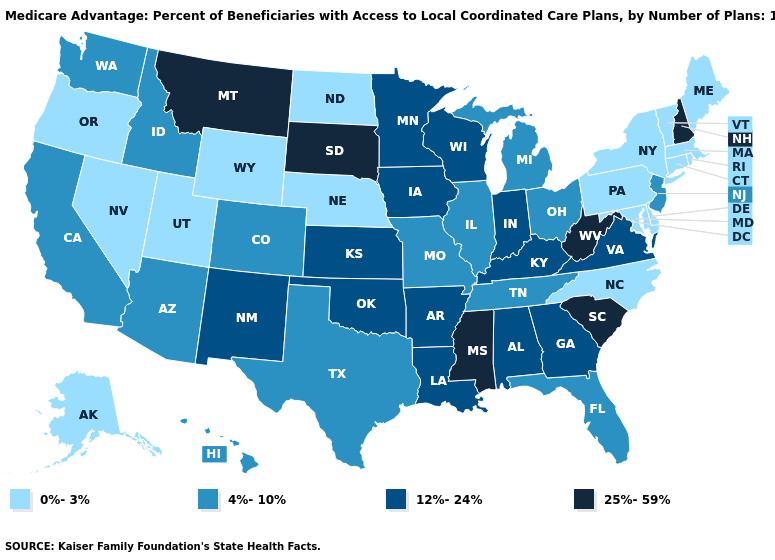Does Georgia have the highest value in the USA?
Give a very brief answer. No. Name the states that have a value in the range 0%-3%?
Write a very short answer. Alaska, Connecticut, Delaware, Massachusetts, Maryland, Maine, North Carolina, North Dakota, Nebraska, Nevada, New York, Oregon, Pennsylvania, Rhode Island, Utah, Vermont, Wyoming. What is the highest value in the USA?
Short answer required. 25%-59%. Among the states that border Maryland , which have the highest value?
Concise answer only. West Virginia. Does the first symbol in the legend represent the smallest category?
Concise answer only. Yes. Name the states that have a value in the range 4%-10%?
Answer briefly. Arizona, California, Colorado, Florida, Hawaii, Idaho, Illinois, Michigan, Missouri, New Jersey, Ohio, Tennessee, Texas, Washington. How many symbols are there in the legend?
Write a very short answer. 4. Name the states that have a value in the range 4%-10%?
Quick response, please. Arizona, California, Colorado, Florida, Hawaii, Idaho, Illinois, Michigan, Missouri, New Jersey, Ohio, Tennessee, Texas, Washington. What is the highest value in the USA?
Be succinct. 25%-59%. Name the states that have a value in the range 4%-10%?
Be succinct. Arizona, California, Colorado, Florida, Hawaii, Idaho, Illinois, Michigan, Missouri, New Jersey, Ohio, Tennessee, Texas, Washington. Name the states that have a value in the range 12%-24%?
Concise answer only. Alabama, Arkansas, Georgia, Iowa, Indiana, Kansas, Kentucky, Louisiana, Minnesota, New Mexico, Oklahoma, Virginia, Wisconsin. What is the value of Florida?
Concise answer only. 4%-10%. Among the states that border Nebraska , which have the lowest value?
Short answer required. Wyoming. What is the lowest value in states that border Mississippi?
Write a very short answer. 4%-10%. Which states have the lowest value in the MidWest?
Be succinct. North Dakota, Nebraska. 